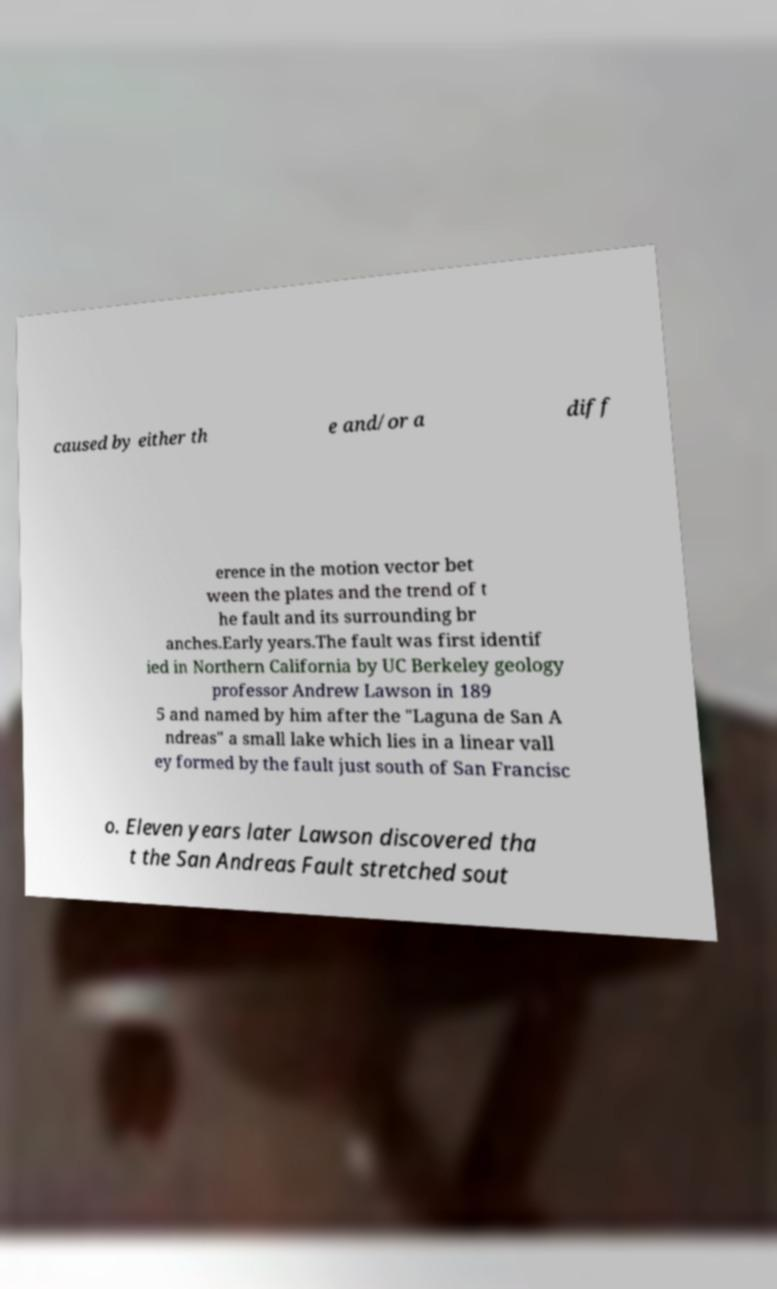Could you extract and type out the text from this image? caused by either th e and/or a diff erence in the motion vector bet ween the plates and the trend of t he fault and its surrounding br anches.Early years.The fault was first identif ied in Northern California by UC Berkeley geology professor Andrew Lawson in 189 5 and named by him after the "Laguna de San A ndreas" a small lake which lies in a linear vall ey formed by the fault just south of San Francisc o. Eleven years later Lawson discovered tha t the San Andreas Fault stretched sout 